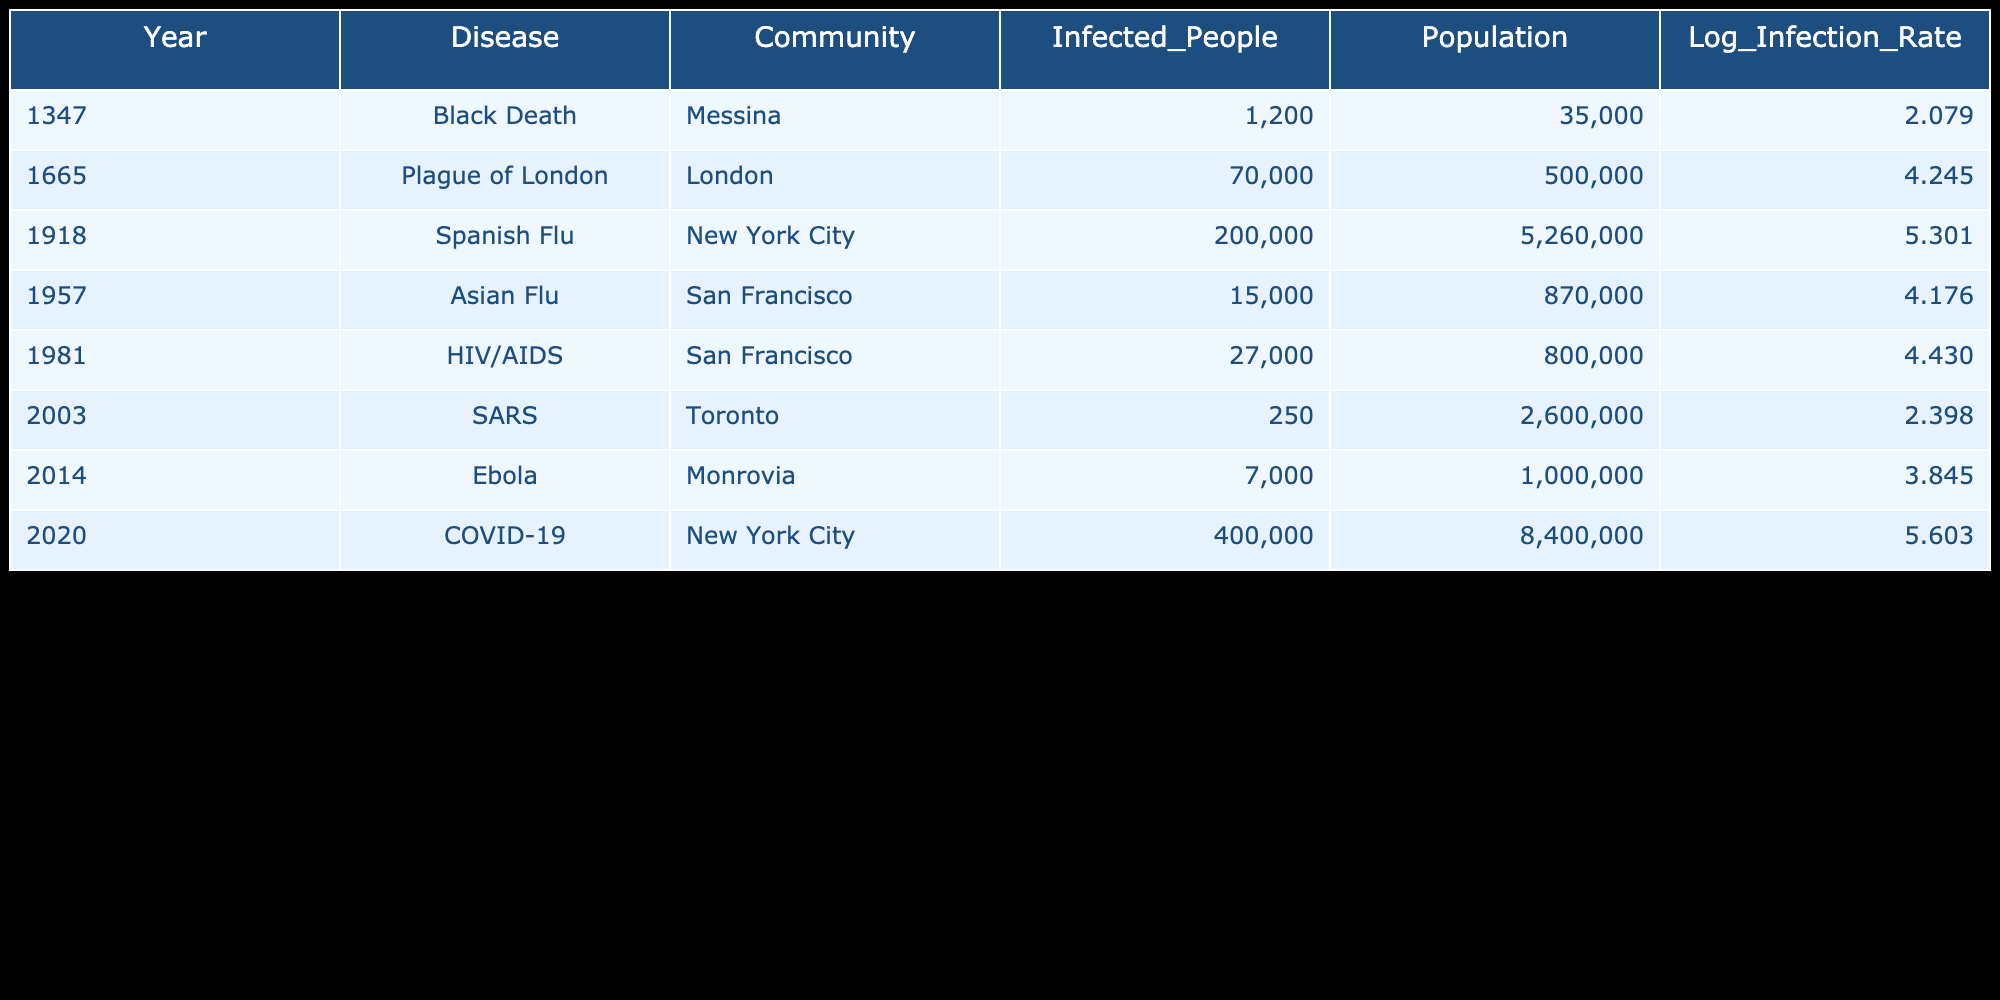What disease caused the highest number of infected people? From the table, we can see the column for infected people. The highest value listed is 400,000 for COVID-19 in New York City in 2020.
Answer: 400,000 What was the population of London during the Plague of London in 1665? Referring to the table, the population for London in 1665 is directly listed as 500,000.
Answer: 500,000 Which community had the lowest logarithmic infection rate? Looking at the "Log_Infection_Rate" column, the lowest value is 2.079 for the Black Death in Messina in 1347.
Answer: 2.079 What is the average number of infected people across all diseases listed? To find the average, we first sum the infected people: 1200 + 70000 + 200000 + 15000 + 27000 + 250 + 7000 + 400000 = 694,457. Then we divide this sum by the number of diseases (8). The average is 86,807.125.
Answer: 86,807.125 Was the number of infected people greater in 1981 (HIV/AIDS) compared to the number in 1957 (Asian Flu)? The table lists 27,000 infected for HIV/AIDS in 1981 and 15,000 for Asian Flu in 1957. Since 27,000 is greater than 15,000, the statement is true.
Answer: Yes Which disease had a logarithmic infection rate above 4 and was reported in the 20th century? From the table, the diseases with a logarithmic infection rate above 4 that occurred in the 20th century are the Spanish Flu (5.301 in 1918), the Asian Flu (4.176 in 1957), and HIV/AIDS (4.430 in 1981).
Answer: Spanish Flu, Asian Flu, HIV/AIDS In what year was the second highest logarithmic infection rate reported, and what was its value? The logarithmic values in order are: 5.603 (2020, COVID-19), 5.301 (1918, Spanish Flu), 4.245 (1665, Plague of London), and others. The second highest infection rate is 5.301 for the Spanish Flu in 1918.
Answer: 1918, 5.301 How many years apart were the outbreaks of the Black Death and COVID-19? The Black Death occurred in 1347 and COVID-19 in 2020. To find the difference in years, we subtract 1347 from 2020, which gives 673 years apart.
Answer: 673 years 